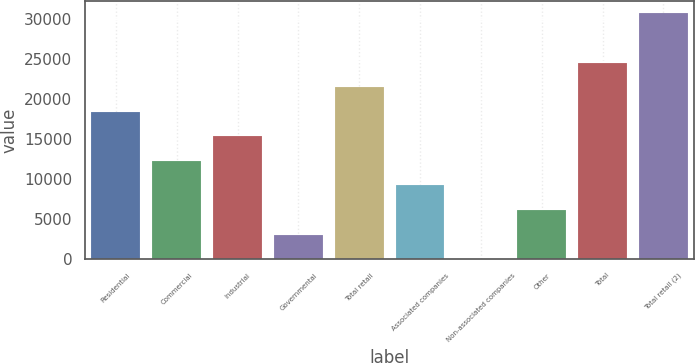Convert chart to OTSL. <chart><loc_0><loc_0><loc_500><loc_500><bar_chart><fcel>Residential<fcel>Commercial<fcel>Industrial<fcel>Governmental<fcel>Total retail<fcel>Associated companies<fcel>Non-associated companies<fcel>Other<fcel>Total<fcel>Total retail (2)<nl><fcel>18391.4<fcel>12262.6<fcel>15327<fcel>3069.4<fcel>21455.8<fcel>9198.2<fcel>5<fcel>6133.8<fcel>24520.2<fcel>30649<nl></chart> 